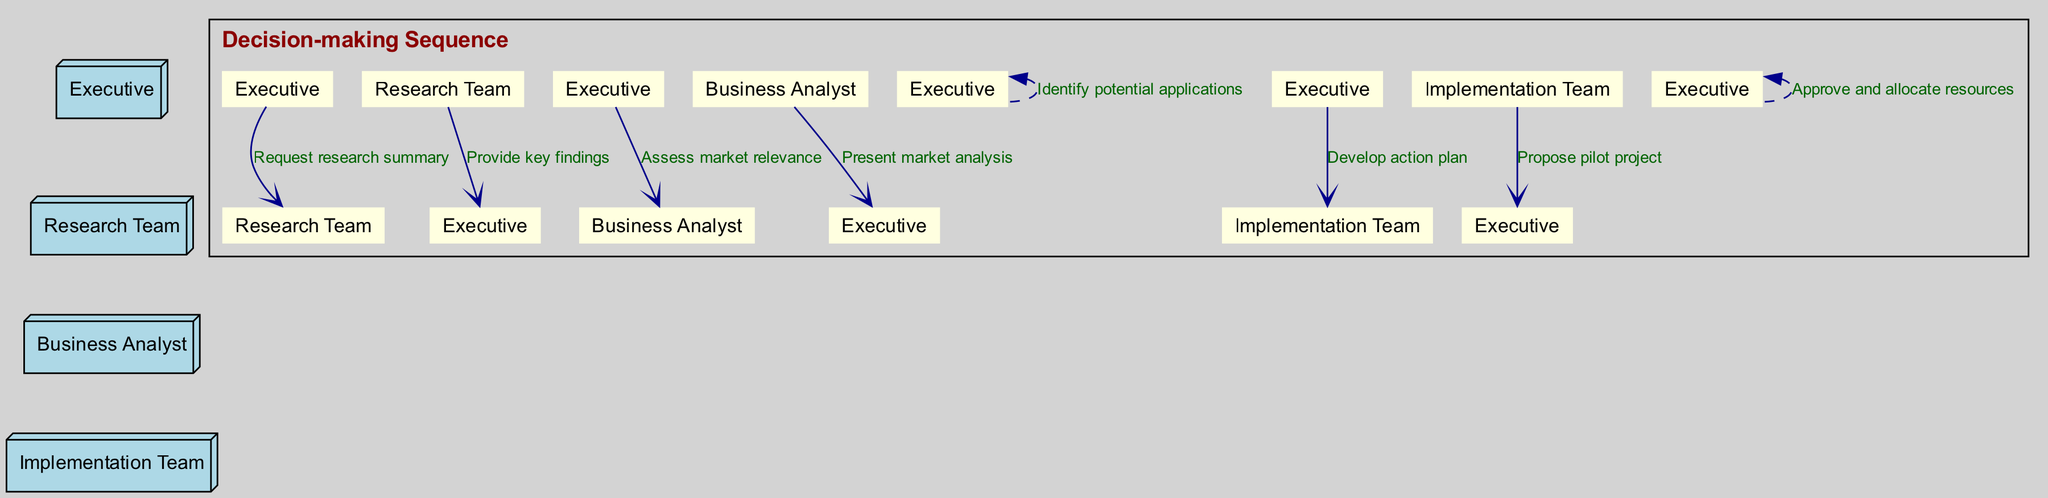What actor initiates the sequence? The diagram shows that the Executive is the first actor to engage with the Research Team by sending a message.
Answer: Executive How many main actors are in the diagram? By counting the distinct actors listed in the diagram, we see there are four: Executive, Research Team, Business Analyst, and Implementation Team.
Answer: 4 What is the first message exchanged in the sequence? The Executive sends a message to the Research Team requesting a research summary, which is the initiating action in the diagram.
Answer: Request research summary Which actor conducts the market relevance assessment? The diagram indicates that the Executive asks the Business Analyst to assess the market relevance based on the information provided by the Research Team.
Answer: Business Analyst How many times does the Executive send messages in the sequence? Upon reviewing the sequence of messages, the Executive sends four messages to different teams throughout the process.
Answer: 4 Which step involves the Implementation Team? The Implementation Team is engaged when the Executive gives them a directive to develop an action plan after identifying potential applications.
Answer: Develop action plan What leads to the approval and resource allocation? After the Implementation Team proposes a pilot project, the Executive evaluates this to approve and allocate the necessary resources based on the findings and analyses previously gathered.
Answer: Propose pilot project What is the purpose of the message "Present market analysis"? This message indicates that the Business Analyst provides insights to the Executive about the market relevance, which is crucial for informed decision-making.
Answer: Present market analysis What happens immediately after the Executive identifies potential applications? Following the identification of potential applications, the Executive instructs the Implementation Team to develop an action plan for those applications.
Answer: Develop action plan 